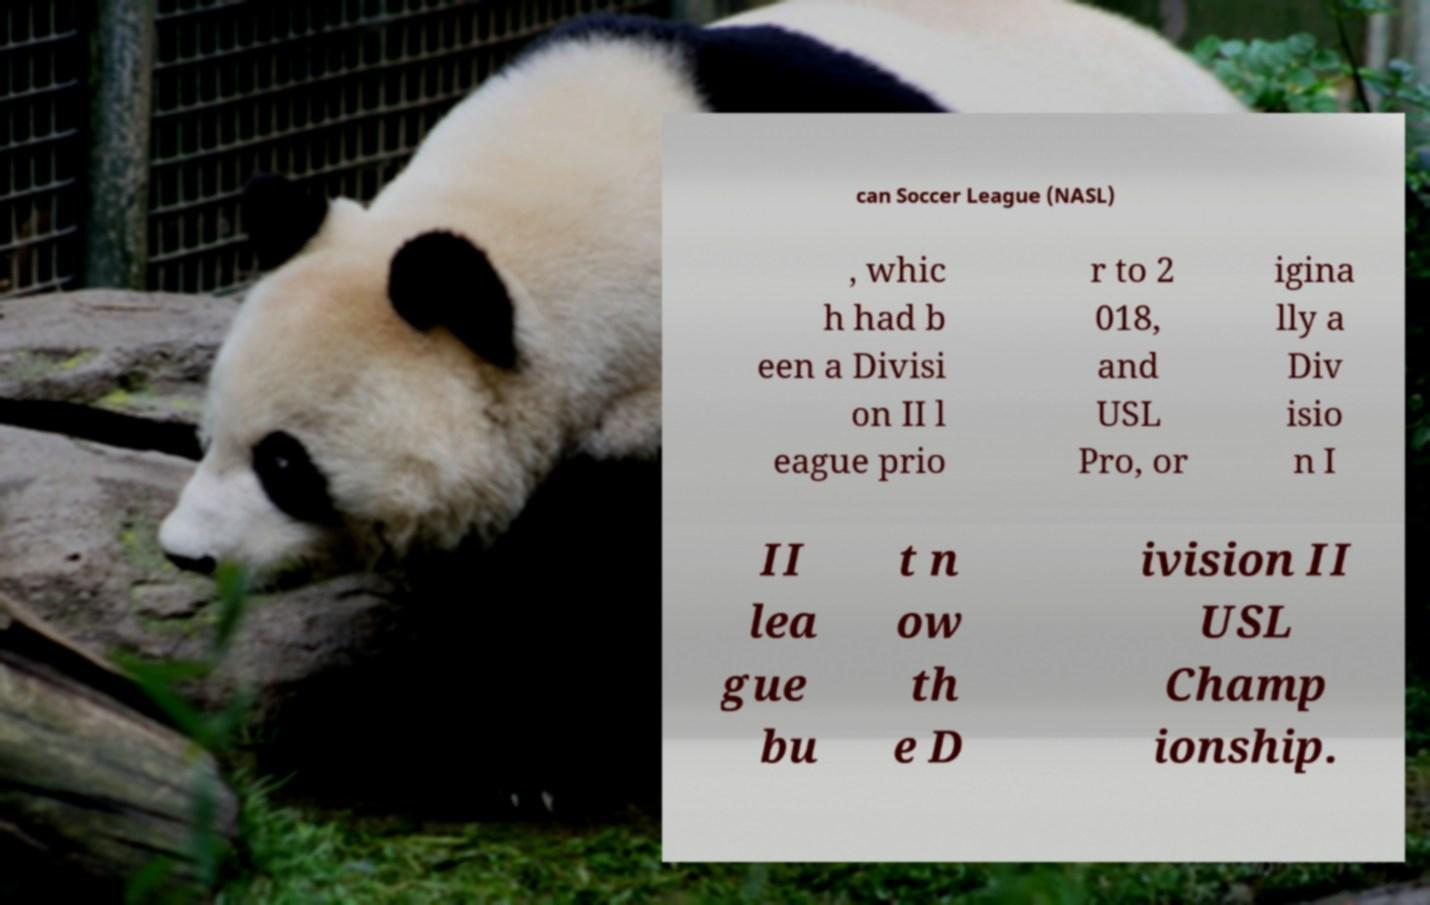There's text embedded in this image that I need extracted. Can you transcribe it verbatim? can Soccer League (NASL) , whic h had b een a Divisi on II l eague prio r to 2 018, and USL Pro, or igina lly a Div isio n I II lea gue bu t n ow th e D ivision II USL Champ ionship. 